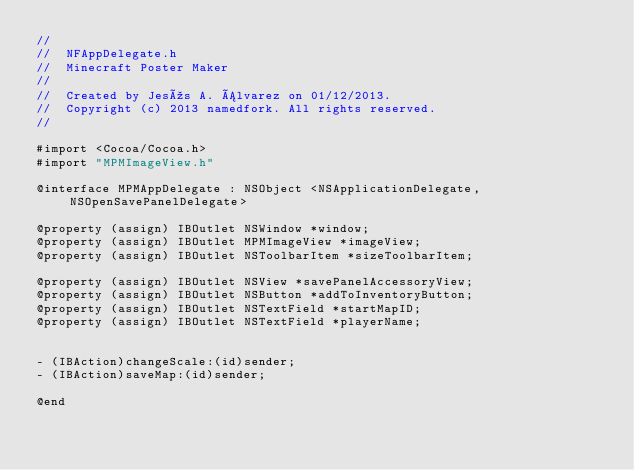<code> <loc_0><loc_0><loc_500><loc_500><_C_>//
//  NFAppDelegate.h
//  Minecraft Poster Maker
//
//  Created by Jesús A. Álvarez on 01/12/2013.
//  Copyright (c) 2013 namedfork. All rights reserved.
//

#import <Cocoa/Cocoa.h>
#import "MPMImageView.h"

@interface MPMAppDelegate : NSObject <NSApplicationDelegate, NSOpenSavePanelDelegate>

@property (assign) IBOutlet NSWindow *window;
@property (assign) IBOutlet MPMImageView *imageView;
@property (assign) IBOutlet NSToolbarItem *sizeToolbarItem;

@property (assign) IBOutlet NSView *savePanelAccessoryView;
@property (assign) IBOutlet NSButton *addToInventoryButton;
@property (assign) IBOutlet NSTextField *startMapID;
@property (assign) IBOutlet NSTextField *playerName;


- (IBAction)changeScale:(id)sender;
- (IBAction)saveMap:(id)sender;

@end
</code> 